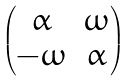Convert formula to latex. <formula><loc_0><loc_0><loc_500><loc_500>\begin{pmatrix} \alpha & \omega \\ - \omega & \alpha \end{pmatrix}</formula> 